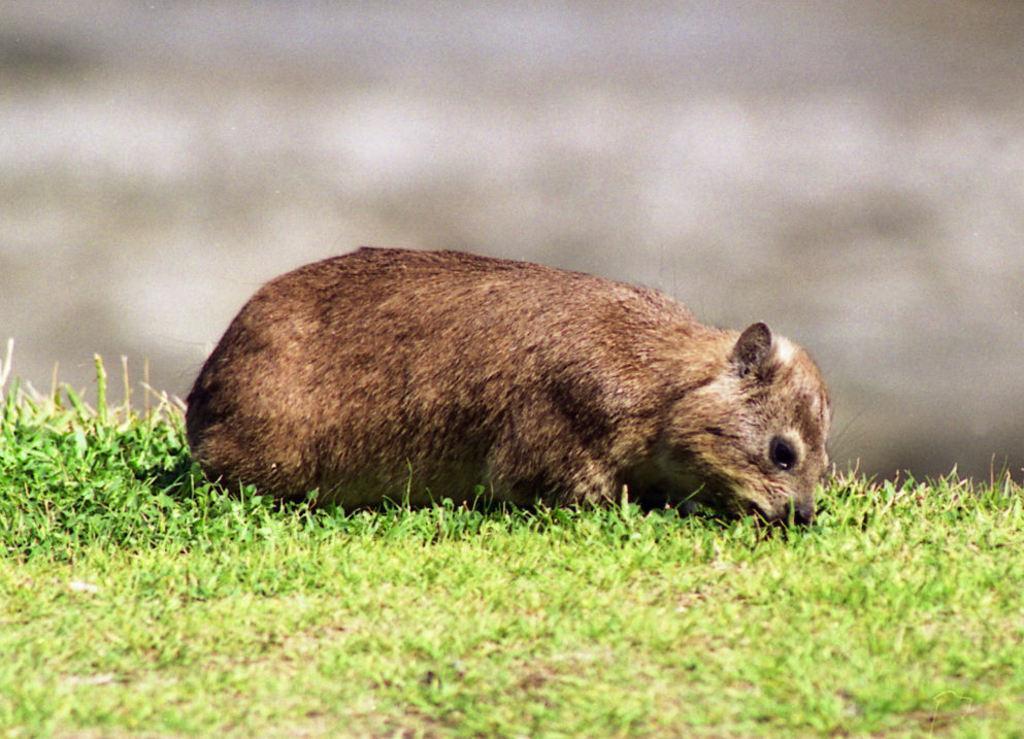Could you give a brief overview of what you see in this image? In this image a animal is lying on the grass land. Background is blurry. 